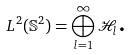<formula> <loc_0><loc_0><loc_500><loc_500>L ^ { 2 } ( \mathbb { S } ^ { 2 } ) = \bigoplus _ { l = 1 } ^ { \infty } \mathcal { H } _ { l } \text {.}</formula> 